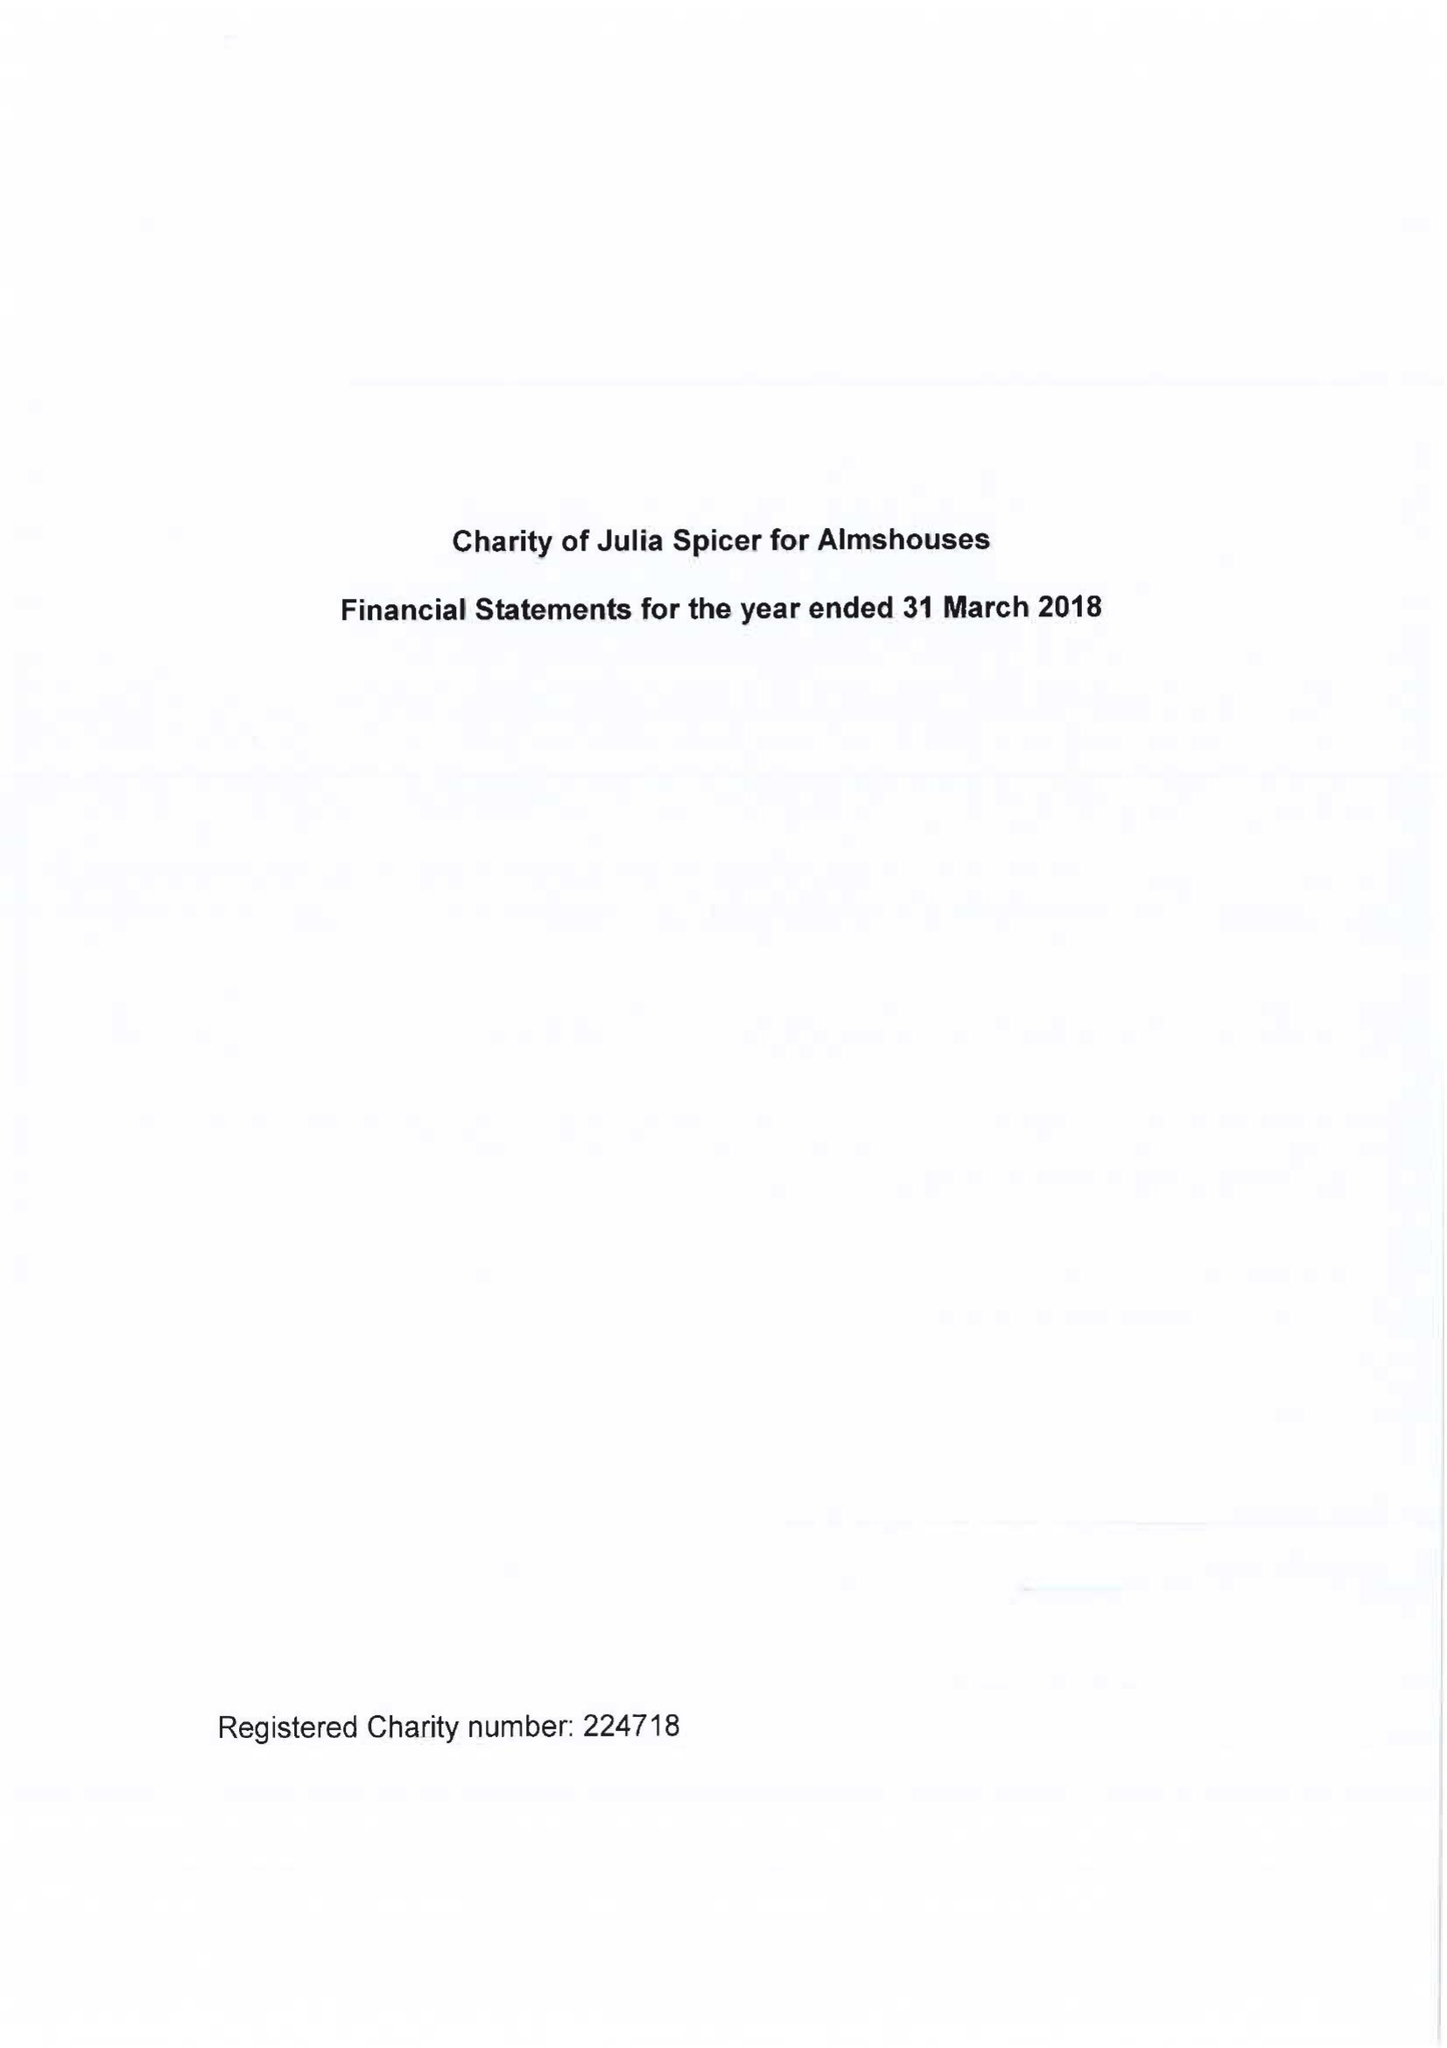What is the value for the address__post_town?
Answer the question using a single word or phrase. CROYDON 